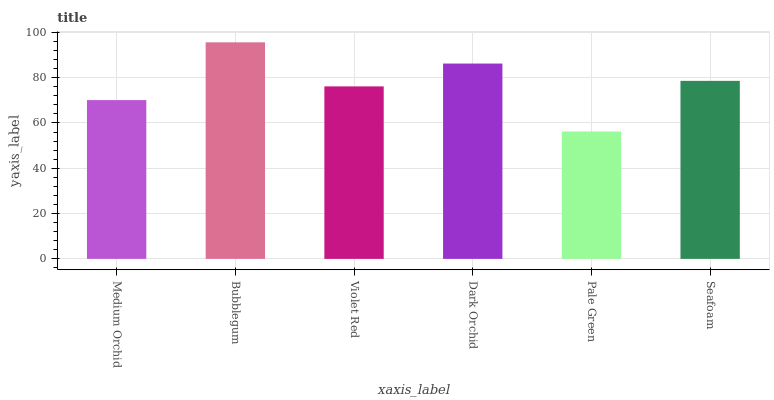Is Pale Green the minimum?
Answer yes or no. Yes. Is Bubblegum the maximum?
Answer yes or no. Yes. Is Violet Red the minimum?
Answer yes or no. No. Is Violet Red the maximum?
Answer yes or no. No. Is Bubblegum greater than Violet Red?
Answer yes or no. Yes. Is Violet Red less than Bubblegum?
Answer yes or no. Yes. Is Violet Red greater than Bubblegum?
Answer yes or no. No. Is Bubblegum less than Violet Red?
Answer yes or no. No. Is Seafoam the high median?
Answer yes or no. Yes. Is Violet Red the low median?
Answer yes or no. Yes. Is Dark Orchid the high median?
Answer yes or no. No. Is Dark Orchid the low median?
Answer yes or no. No. 